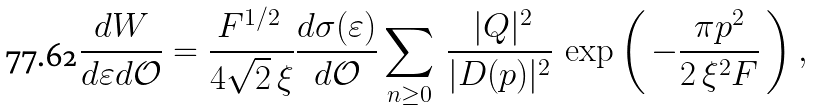<formula> <loc_0><loc_0><loc_500><loc_500>\frac { d W } { d \varepsilon d \mathcal { O } } = \frac { { F } ^ { 1 / 2 } \, } { 4 \sqrt { 2 } \, \xi } \frac { d \sigma ( \varepsilon ) } { d \mathcal { O } } \sum _ { n \geq 0 } \, \frac { \, | Q | ^ { 2 } } { | D ( p ) | ^ { 2 } } \, \exp \left ( \, - \frac { \pi p ^ { 2 } } { 2 \, \xi ^ { 2 } F } \, \right ) ,</formula> 